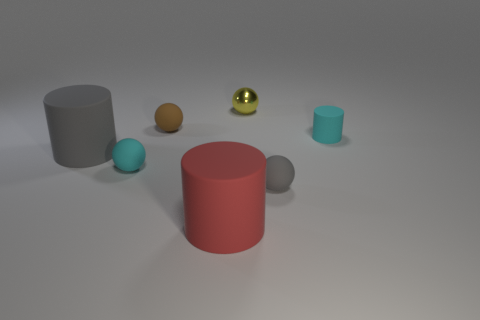There is a gray rubber thing that is the same size as the yellow shiny sphere; what is its shape?
Make the answer very short. Sphere. How many big objects are yellow spheres or brown cylinders?
Keep it short and to the point. 0. What color is the big object that is made of the same material as the red cylinder?
Your response must be concise. Gray. There is a cyan matte object that is in front of the cyan cylinder; is its shape the same as the gray rubber thing right of the brown thing?
Your response must be concise. Yes. How many matte objects are small yellow balls or large purple balls?
Keep it short and to the point. 0. There is a tiny ball that is the same color as the small rubber cylinder; what is its material?
Give a very brief answer. Rubber. Is there any other thing that is the same shape as the yellow metallic thing?
Provide a succinct answer. Yes. There is a gray thing right of the metallic ball; what is it made of?
Provide a succinct answer. Rubber. Is the material of the gray thing right of the red cylinder the same as the red cylinder?
Your response must be concise. Yes. What number of things are either small rubber balls or tiny spheres that are right of the small yellow ball?
Your answer should be compact. 3. 